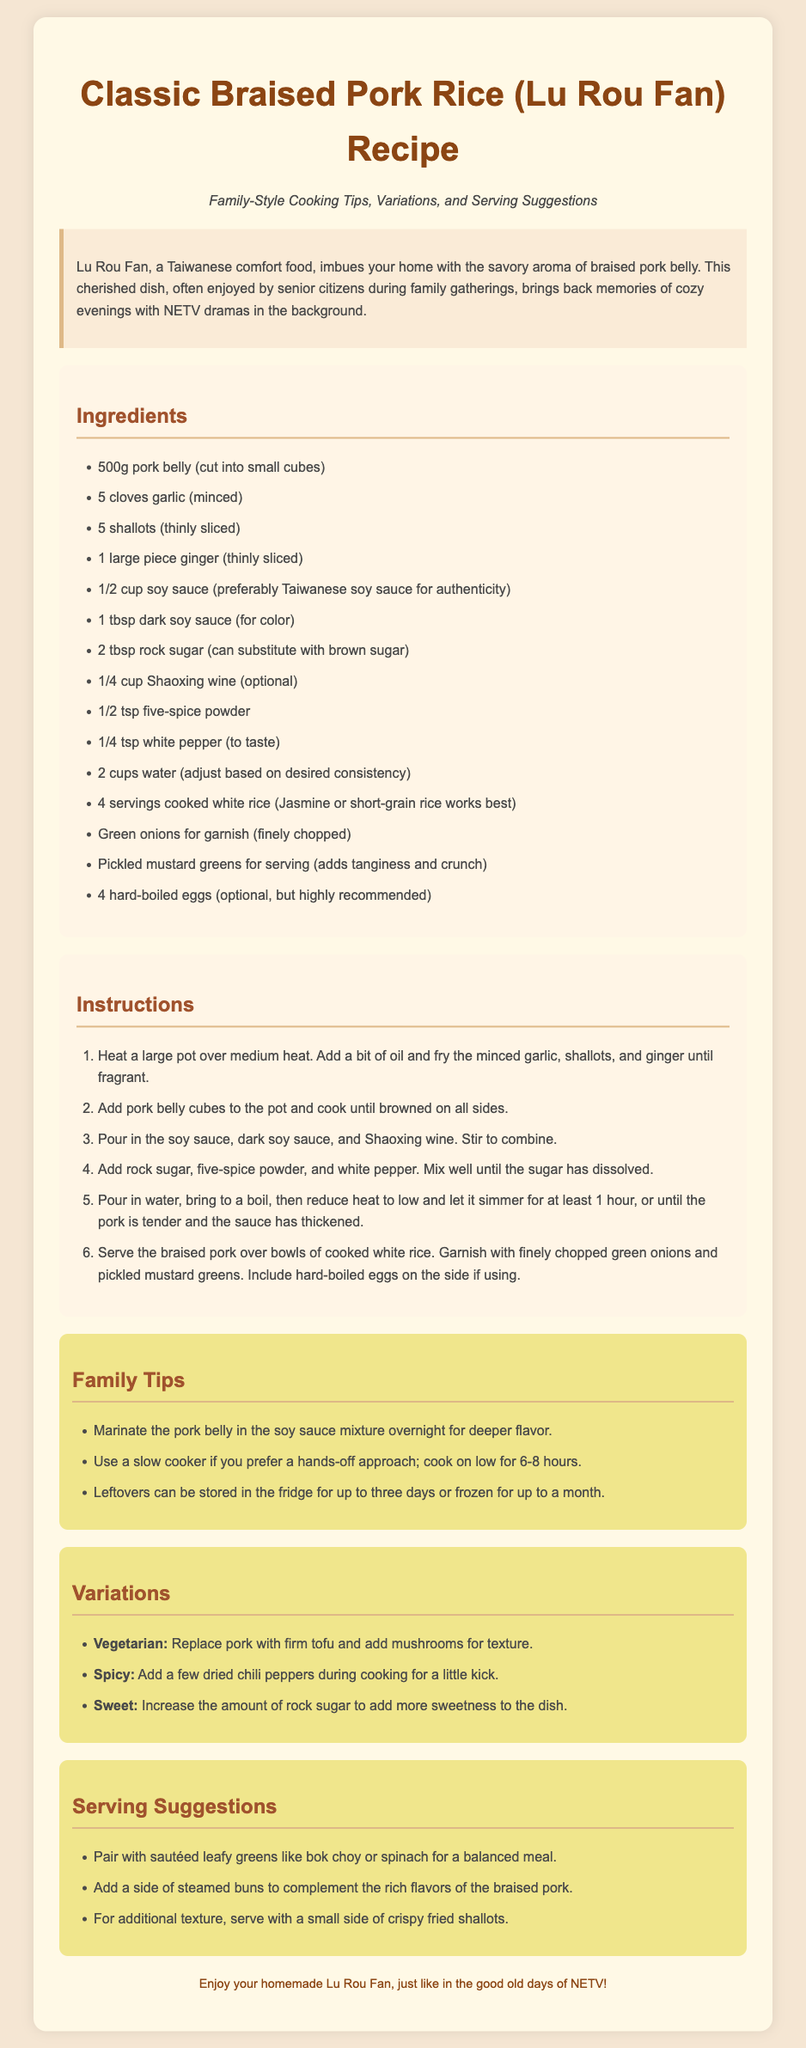What are the main ingredients for Lu Rou Fan? The ingredients section lists all the components required for cooking Lu Rou Fan.
Answer: 500g pork belly, garlic, shallots, ginger, soy sauce, dark soy sauce, rock sugar, Shaoxing wine, five-spice powder, white pepper, water, rice, green onions, pickled mustard greens, hard-boiled eggs How long should the pork simmer? The instructions specify the cooking time for the pork to reach tenderness.
Answer: 1 hour What is the optional ingredient for this recipe? The ingredients list highlights optional components that can enhance the dish.
Answer: Shaoxing wine What can be used instead of pork for a vegetarian version? The variations section explains alternatives for different dietary needs.
Answer: Firm tofu What is a suggested side dish to pair with Lu Rou Fan? The serving suggestions provide ideas for complementary dishes to enjoy with Lu Rou Fan.
Answer: Sautéed leafy greens Which ingredient adds sweetness to the dish? The ingredients section identifies components that contribute to the dish's flavor profile.
Answer: Rock sugar How should leftovers be stored? The family tips provide guidance on the preservation of excess cooked dish.
Answer: Fridge or frozen What type of rice works best for this recipe? The ingredients specify the ideal rice type to use, enhancing texture and flavor.
Answer: Jasmine or short-grain rice 